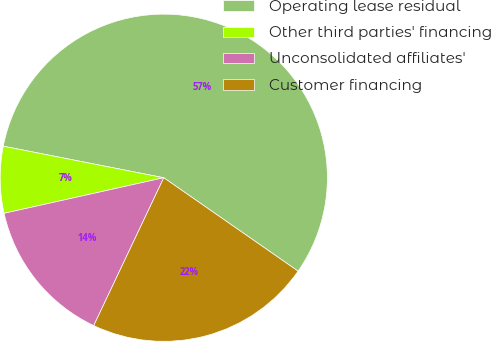Convert chart. <chart><loc_0><loc_0><loc_500><loc_500><pie_chart><fcel>Operating lease residual<fcel>Other third parties' financing<fcel>Unconsolidated affiliates'<fcel>Customer financing<nl><fcel>56.58%<fcel>6.58%<fcel>14.47%<fcel>22.37%<nl></chart> 